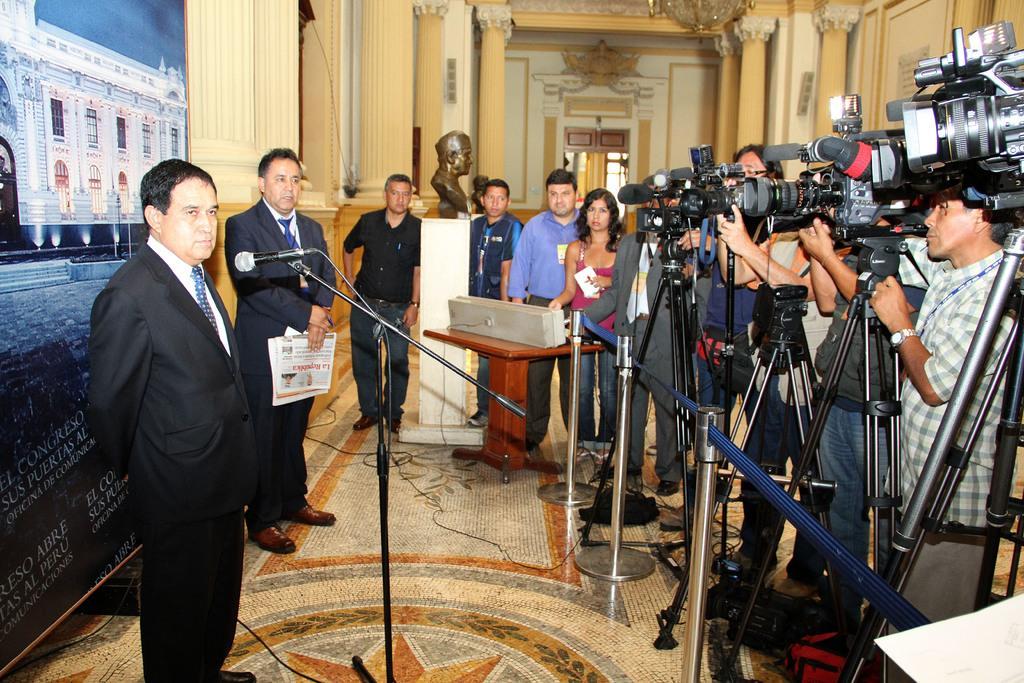How would you summarize this image in a sentence or two? Group of people standing and this person holding paper,these persons are holding camera with stands,in front of this person we can see microphone with stand. On the background we can see wall,pillars,banner,statue. This is floor. 